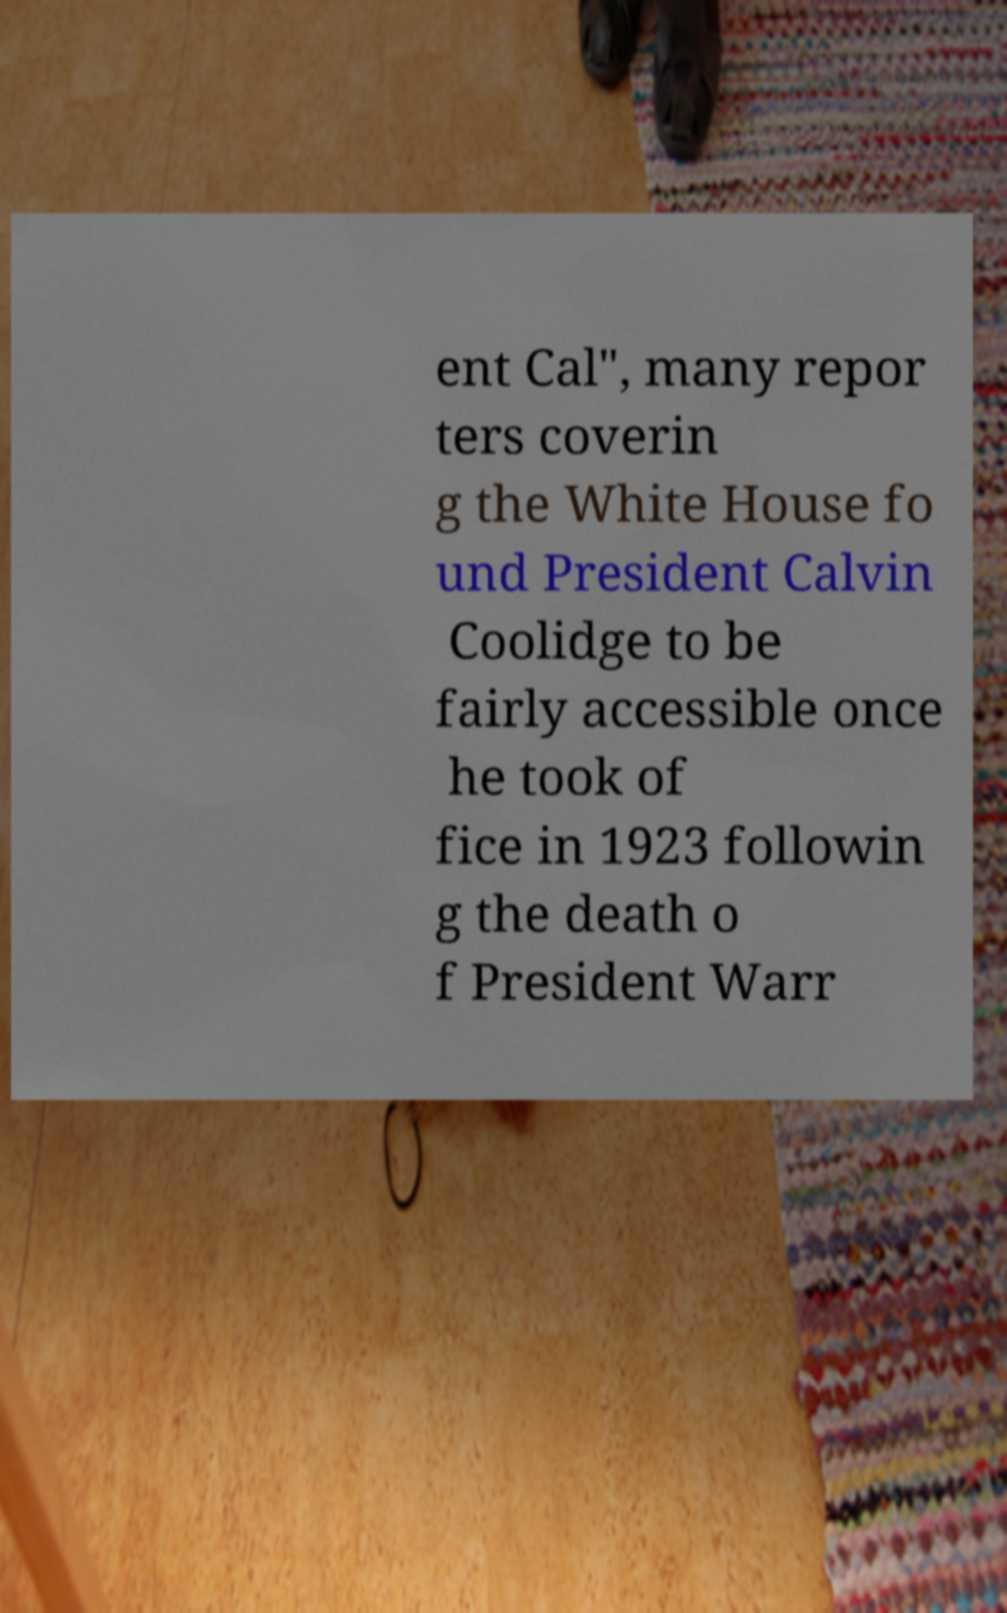Could you assist in decoding the text presented in this image and type it out clearly? ent Cal", many repor ters coverin g the White House fo und President Calvin Coolidge to be fairly accessible once he took of fice in 1923 followin g the death o f President Warr 